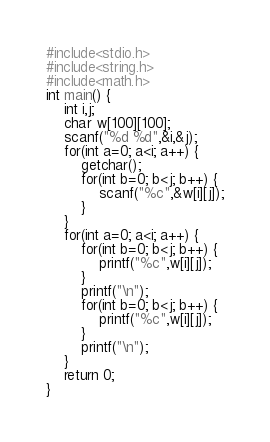<code> <loc_0><loc_0><loc_500><loc_500><_C_>#include<stdio.h>
#include<string.h>
#include<math.h>
int main() {
	int i,j;
	char w[100][100];
	scanf("%d %d",&i,&j);
	for(int a=0; a<i; a++) {
		getchar();
		for(int b=0; b<j; b++) {
			scanf("%c",&w[i][j]);
		}
	}
	for(int a=0; a<i; a++) {
		for(int b=0; b<j; b++) {
			printf("%c",w[i][j]);
		}
		printf("\n");
		for(int b=0; b<j; b++) {
			printf("%c",w[i][j]);
		}
		printf("\n");
	}
	return 0;
}</code> 